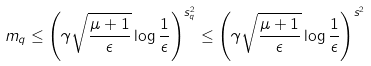<formula> <loc_0><loc_0><loc_500><loc_500>m _ { q } \leq \left ( \gamma \sqrt { \frac { \mu + 1 } { \epsilon } } \log \frac { 1 } { \epsilon } \right ) ^ { s _ { q } ^ { 2 } } \leq \left ( \gamma \sqrt { \frac { \mu + 1 } { \epsilon } } \log \frac { 1 } { \epsilon } \right ) ^ { s ^ { 2 } }</formula> 